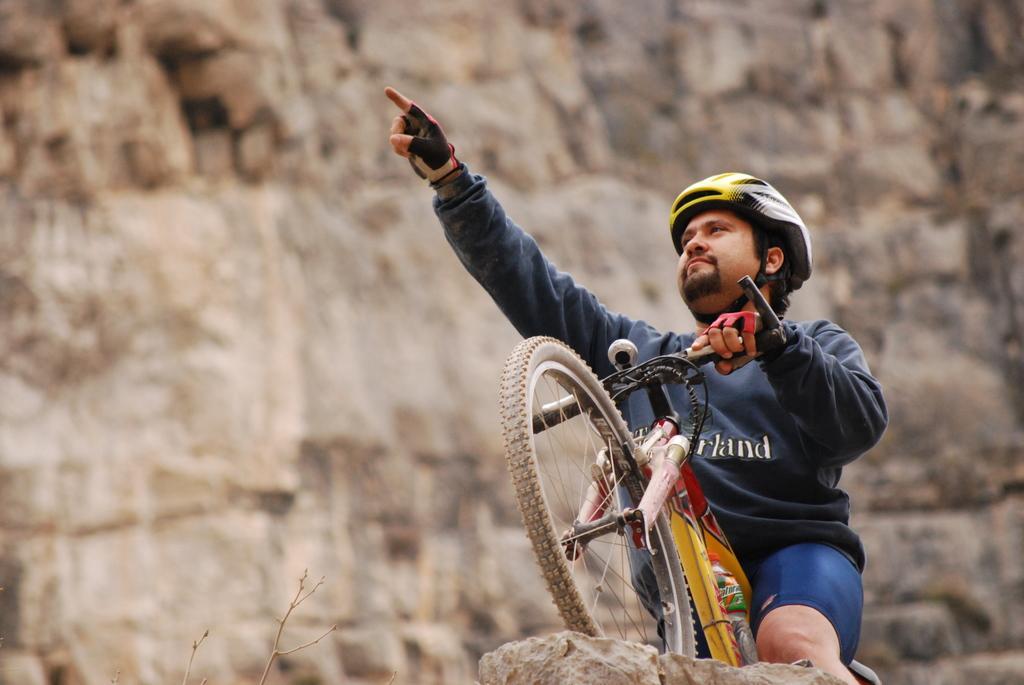Can you describe this image briefly? A man wearing a t-shirt is riding a bicycle. He is wearing a helmet on his head. To the both hands he is having a gloves. He stood on the top of the rock. 